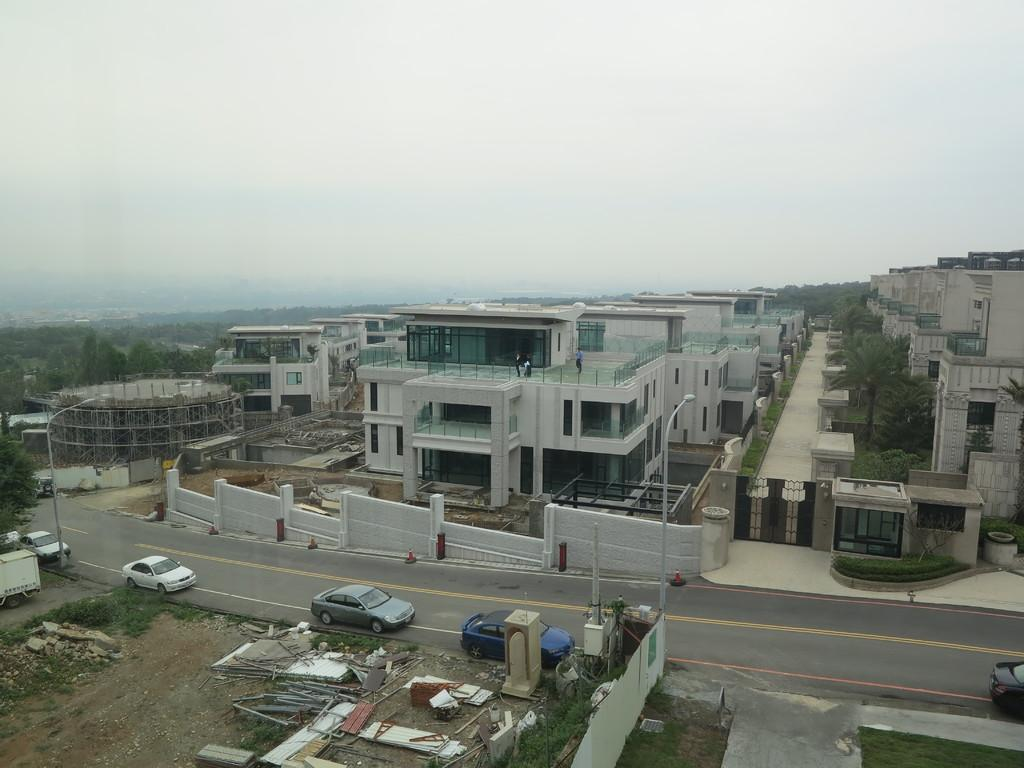What type of structures can be seen in the image? There are buildings in the image. What type of doors are featured on the buildings? There are metal doors in the image. What type of natural environment is visible in the image? There are surrounding trees visible in the image. What type of transportation is present on the road in the image? Vehicles are present on the road in the image. What is visible at the top of the image? The sky is visible at the top of the image. How many eyes can be seen on the buildings in the image? There are no eyes present on the buildings in the image. What type of operation is being conducted in the image? There is no operation being conducted in the image; it simply shows buildings, metal doors, trees, vehicles, and the sky. 